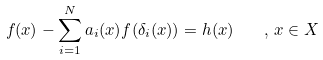<formula> <loc_0><loc_0><loc_500><loc_500>f ( x ) - \sum _ { i = 1 } ^ { N } a _ { i } ( x ) f ( \delta _ { i } ( x ) ) = h ( x ) \quad , \, x \in X</formula> 